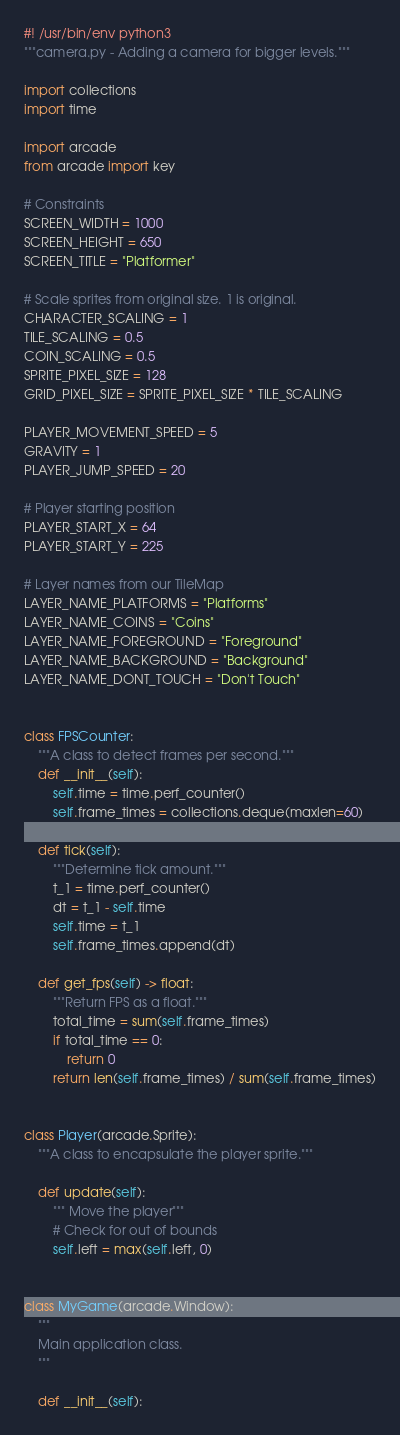Convert code to text. <code><loc_0><loc_0><loc_500><loc_500><_Python_>#! /usr/bin/env python3
"""camera.py - Adding a camera for bigger levels."""

import collections
import time

import arcade
from arcade import key

# Constraints
SCREEN_WIDTH = 1000
SCREEN_HEIGHT = 650
SCREEN_TITLE = "Platformer"

# Scale sprites from original size. 1 is original.
CHARACTER_SCALING = 1
TILE_SCALING = 0.5
COIN_SCALING = 0.5
SPRITE_PIXEL_SIZE = 128
GRID_PIXEL_SIZE = SPRITE_PIXEL_SIZE * TILE_SCALING

PLAYER_MOVEMENT_SPEED = 5
GRAVITY = 1
PLAYER_JUMP_SPEED = 20

# Player starting position
PLAYER_START_X = 64
PLAYER_START_Y = 225

# Layer names from our TileMap
LAYER_NAME_PLATFORMS = "Platforms"
LAYER_NAME_COINS = "Coins"
LAYER_NAME_FOREGROUND = "Foreground"
LAYER_NAME_BACKGROUND = "Background"
LAYER_NAME_DONT_TOUCH = "Don't Touch"


class FPSCounter:
    """A class to detect frames per second."""
    def __init__(self):
        self.time = time.perf_counter()
        self.frame_times = collections.deque(maxlen=60)

    def tick(self):
        """Determine tick amount."""
        t_1 = time.perf_counter()
        dt = t_1 - self.time
        self.time = t_1
        self.frame_times.append(dt)

    def get_fps(self) -> float:
        """Return FPS as a float."""
        total_time = sum(self.frame_times)
        if total_time == 0:
            return 0
        return len(self.frame_times) / sum(self.frame_times)


class Player(arcade.Sprite):
    """A class to encapsulate the player sprite."""

    def update(self):
        """ Move the player"""
        # Check for out of bounds
        self.left = max(self.left, 0)


class MyGame(arcade.Window):
    """
    Main application class.
    """

    def __init__(self):</code> 